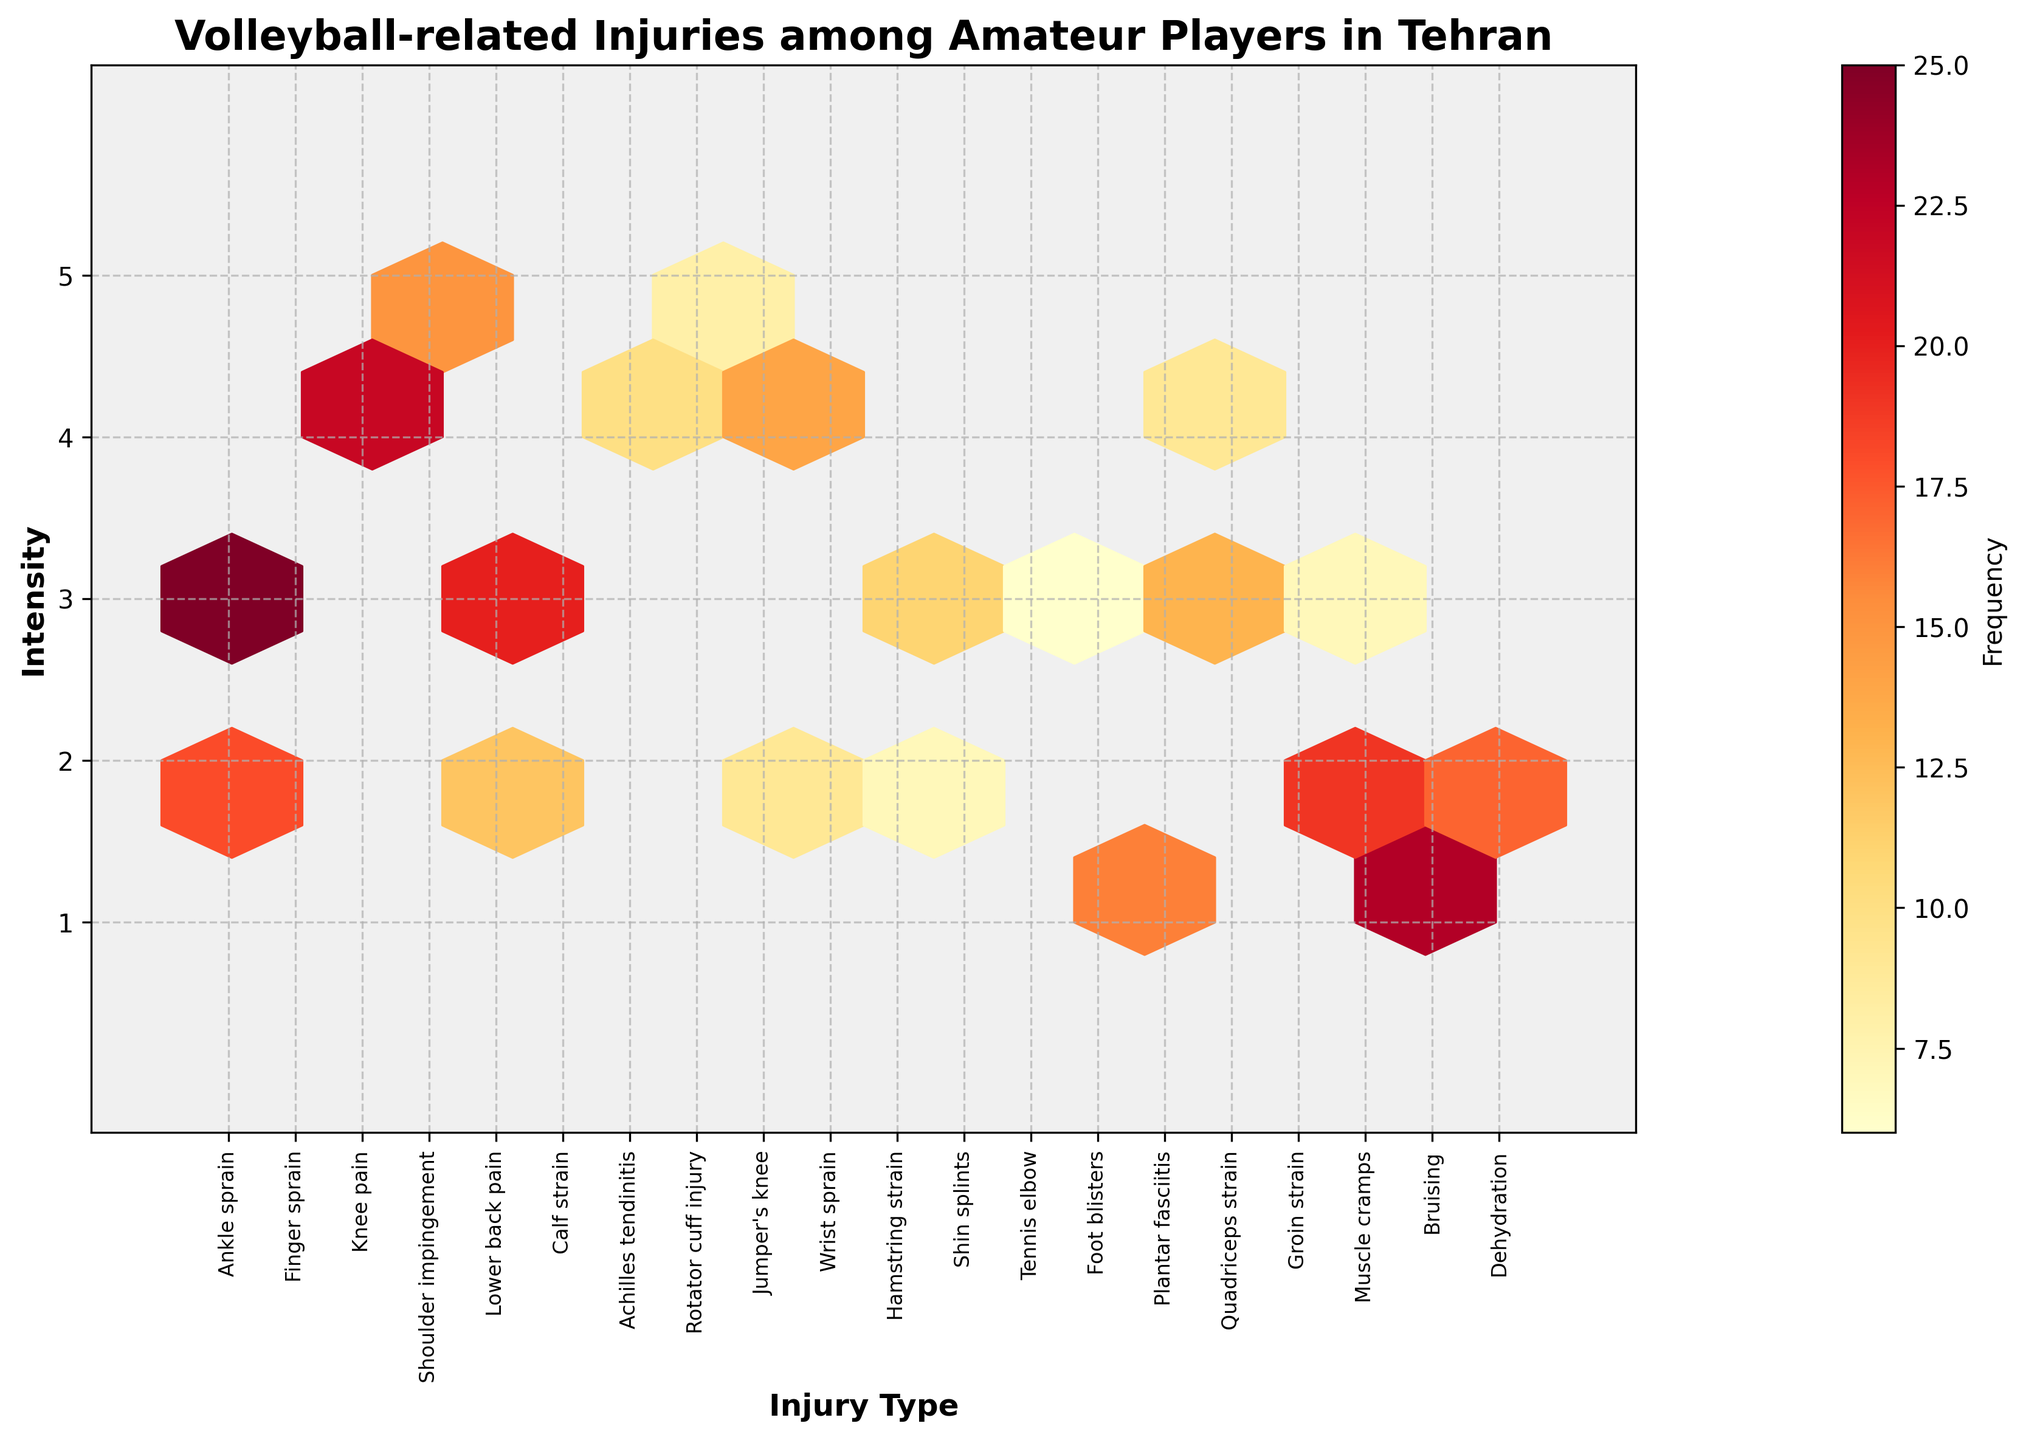What's the title of the figure? The title is displayed at the top center of the figure in larger and bold font.
Answer: Volleyball-related Injuries among Amateur Players in Tehran What are the x- and y-axis labels? The x-axis label, which represents the injury type, is located at the bottom of the figure and is bold and larger in size. The y-axis label, which represents the intensity, is found on the left side in bold text as well.
Answer: Injury Type, Intensity How many different types of injuries are shown on the plot? Each injury type is represented by a unique tick on the x-axis. By counting these ticks, we can determine the number of injury types displayed. There are 20 ticks on the x-axis.
Answer: 20 Which injury has the highest frequency? By examining the color intensity within each hexagon, which represents frequency, the brightest hexagon indicates the highest frequency. The brightest hexagon corresponds to the "Ankle sprain" injury.
Answer: Ankle sprain What is the frequency range shown by the color bar? The color bar illustrates the range of frequency values, with a specific color gradient. The lowest value indicated by the lightest color and the highest by the darkest. The range is from 6 to 25.
Answer: 6 to 25 Which injury has an intensity of 5 and what is its frequency? By locating the hexagons with an intensity of 5 on the y-axis and then identifying the corresponding x-axis value and frequency color, we can determine the injury type and frequency. The injury "Shoulder impingement" has an intensity of 5 and its frequency is 15.
Answer: Shoulder impingement, 15 What is the median frequency of injuries with an intensity of 3? First, identify and list the frequencies of injuries with an intensity of 3, then find their median. Frequencies are (25, 20, 11, 13, 7, 6). The median frequency is (11 + 13) / 2 = 12.
Answer: 12 Which injury occurs more frequently, "Calf strain" or "Jumper's knee" and what are their frequencies? By finding the specific hexagons for each injury on the plot and comparing their color intensity, associated with frequency, we can determine which injury is more frequent. "Calf strain" has a frequency of 12 whereas "Jumper's knee" has a frequency of 14.
Answer: Jumper's knee, 14 Among the injuries with intensity 2, which injury has the second highest frequency? First, identify the injuries with intensity 2, then sort their frequencies in descending order and pick the second highest. Frequencies are (18, 12, 9, 7, 19, 17); hence, the second highest is 18 for "Finger sprain."
Answer: Finger sprain What overall trend do you observe in the relationship between intensity and frequency of injuries? Observing the color distribution across varying intensities can reveal if higher intensity injuries occur more or less frequently. Injuries with higher intensity (1 and 2) tend to have higher frequencies as shown by the more intense colors at these levels.
Answer: Higher frequent injuries tend to have lower intensity 